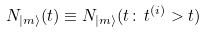Convert formula to latex. <formula><loc_0><loc_0><loc_500><loc_500>N _ { | m \rangle } ( t ) \equiv N _ { | m \rangle } ( t \colon \, t ^ { ( i ) } > t )</formula> 